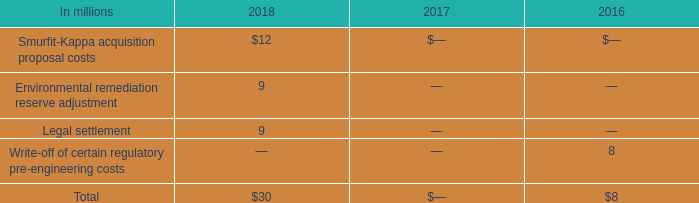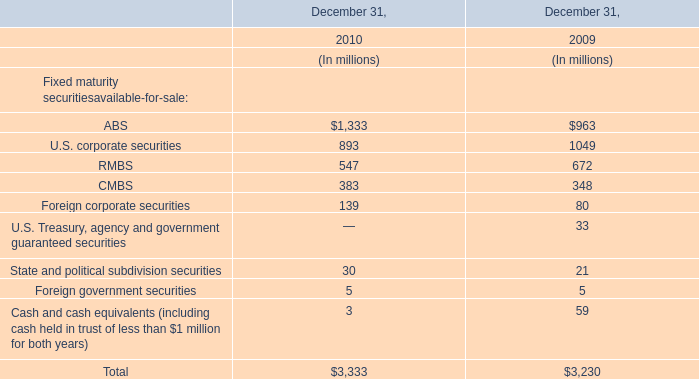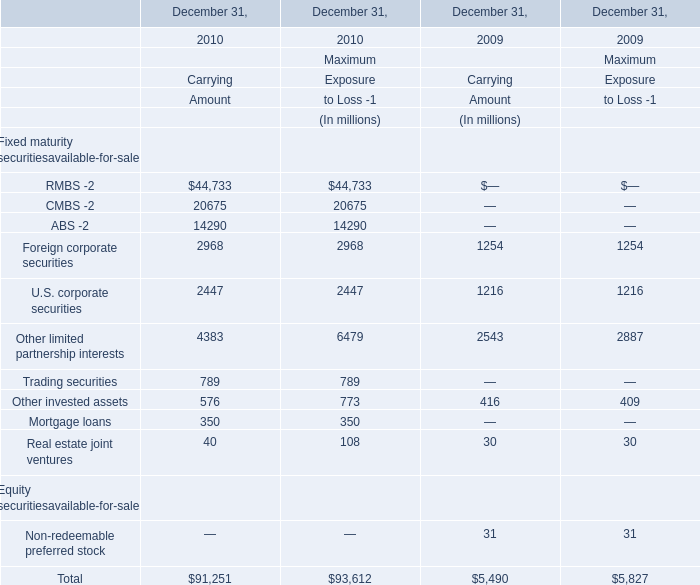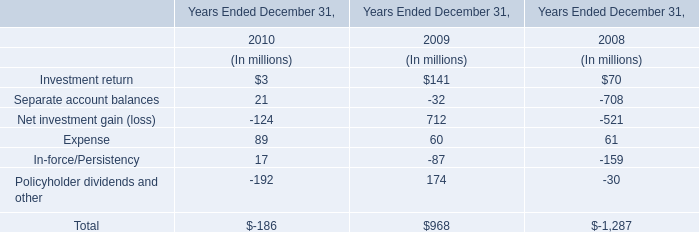What is the ratio of all Carrying Amount that are smaller than 400 to the sum of Carrying Amount, in 2010 for Fixed maturity securitiesavailable-for-sale? 
Computations: ((40 + 350) / (((((((((44733 + 20675) + 14290) + 2968) + 2447) + 4383) + 789) + 576) + 350) + 40))
Answer: 0.00427. 